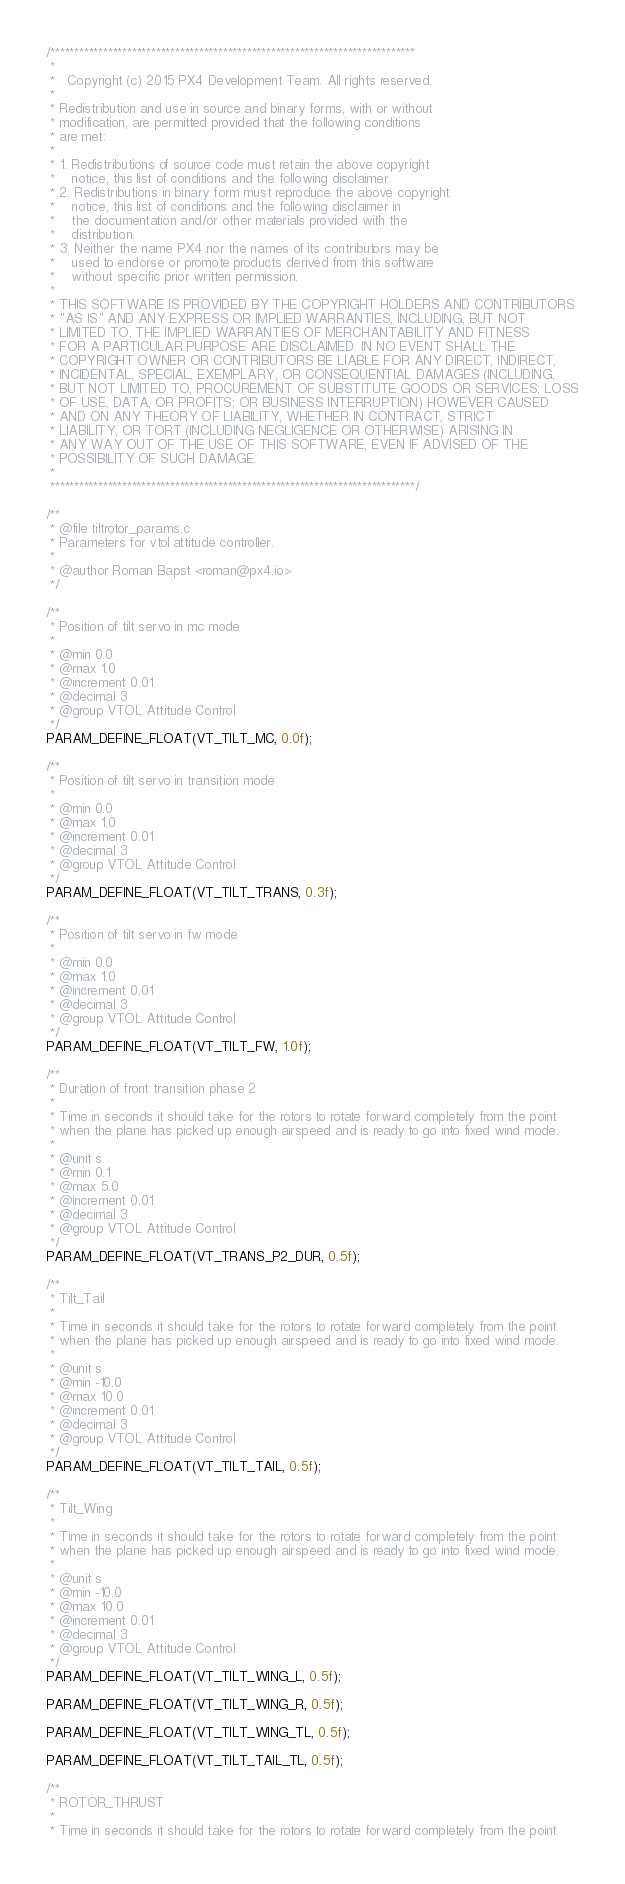<code> <loc_0><loc_0><loc_500><loc_500><_C_>/****************************************************************************
 *
 *   Copyright (c) 2015 PX4 Development Team. All rights reserved.
 *
 * Redistribution and use in source and binary forms, with or without
 * modification, are permitted provided that the following conditions
 * are met:
 *
 * 1. Redistributions of source code must retain the above copyright
 *    notice, this list of conditions and the following disclaimer.
 * 2. Redistributions in binary form must reproduce the above copyright
 *    notice, this list of conditions and the following disclaimer in
 *    the documentation and/or other materials provided with the
 *    distribution.
 * 3. Neither the name PX4 nor the names of its contributors may be
 *    used to endorse or promote products derived from this software
 *    without specific prior written permission.
 *
 * THIS SOFTWARE IS PROVIDED BY THE COPYRIGHT HOLDERS AND CONTRIBUTORS
 * "AS IS" AND ANY EXPRESS OR IMPLIED WARRANTIES, INCLUDING, BUT NOT
 * LIMITED TO, THE IMPLIED WARRANTIES OF MERCHANTABILITY AND FITNESS
 * FOR A PARTICULAR PURPOSE ARE DISCLAIMED. IN NO EVENT SHALL THE
 * COPYRIGHT OWNER OR CONTRIBUTORS BE LIABLE FOR ANY DIRECT, INDIRECT,
 * INCIDENTAL, SPECIAL, EXEMPLARY, OR CONSEQUENTIAL DAMAGES (INCLUDING,
 * BUT NOT LIMITED TO, PROCUREMENT OF SUBSTITUTE GOODS OR SERVICES; LOSS
 * OF USE, DATA, OR PROFITS; OR BUSINESS INTERRUPTION) HOWEVER CAUSED
 * AND ON ANY THEORY OF LIABILITY, WHETHER IN CONTRACT, STRICT
 * LIABILITY, OR TORT (INCLUDING NEGLIGENCE OR OTHERWISE) ARISING IN
 * ANY WAY OUT OF THE USE OF THIS SOFTWARE, EVEN IF ADVISED OF THE
 * POSSIBILITY OF SUCH DAMAGE.
 *
 ****************************************************************************/

/**
 * @file tiltrotor_params.c
 * Parameters for vtol attitude controller.
 *
 * @author Roman Bapst <roman@px4.io>
 */

/**
 * Position of tilt servo in mc mode
 *
 * @min 0.0
 * @max 1.0
 * @increment 0.01
 * @decimal 3
 * @group VTOL Attitude Control
 */
PARAM_DEFINE_FLOAT(VT_TILT_MC, 0.0f);

/**
 * Position of tilt servo in transition mode
 *
 * @min 0.0
 * @max 1.0
 * @increment 0.01
 * @decimal 3
 * @group VTOL Attitude Control
 */
PARAM_DEFINE_FLOAT(VT_TILT_TRANS, 0.3f);

/**
 * Position of tilt servo in fw mode
 *
 * @min 0.0
 * @max 1.0
 * @increment 0.01
 * @decimal 3
 * @group VTOL Attitude Control
 */
PARAM_DEFINE_FLOAT(VT_TILT_FW, 1.0f);

/**
 * Duration of front transition phase 2
 *
 * Time in seconds it should take for the rotors to rotate forward completely from the point
 * when the plane has picked up enough airspeed and is ready to go into fixed wind mode.
 *
 * @unit s
 * @min 0.1
 * @max 5.0
 * @increment 0.01
 * @decimal 3
 * @group VTOL Attitude Control
 */
PARAM_DEFINE_FLOAT(VT_TRANS_P2_DUR, 0.5f);

/**
 * Tilt_Tail
 *
 * Time in seconds it should take for the rotors to rotate forward completely from the point
 * when the plane has picked up enough airspeed and is ready to go into fixed wind mode.
 *
 * @unit s
 * @min -10.0
 * @max 10.0
 * @increment 0.01
 * @decimal 3
 * @group VTOL Attitude Control
 */
PARAM_DEFINE_FLOAT(VT_TILT_TAIL, 0.5f);

/**
 * Tilt_Wing
 *
 * Time in seconds it should take for the rotors to rotate forward completely from the point
 * when the plane has picked up enough airspeed and is ready to go into fixed wind mode.
 *
 * @unit s
 * @min -10.0
 * @max 10.0
 * @increment 0.01
 * @decimal 3
 * @group VTOL Attitude Control
 */
PARAM_DEFINE_FLOAT(VT_TILT_WING_L, 0.5f);

PARAM_DEFINE_FLOAT(VT_TILT_WING_R, 0.5f);

PARAM_DEFINE_FLOAT(VT_TILT_WING_TL, 0.5f);

PARAM_DEFINE_FLOAT(VT_TILT_TAIL_TL, 0.5f);

/**
 * ROTOR_THRUST
 *
 * Time in seconds it should take for the rotors to rotate forward completely from the point</code> 